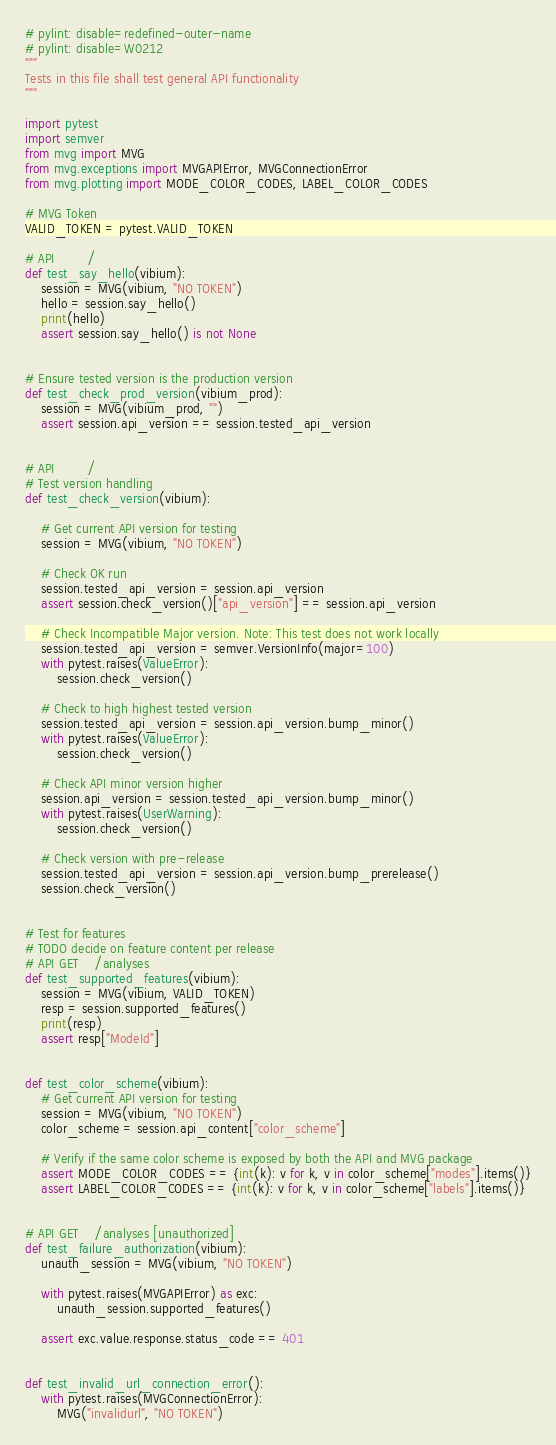<code> <loc_0><loc_0><loc_500><loc_500><_Python_># pylint: disable=redefined-outer-name
# pylint: disable=W0212
"""
Tests in this file shall test general API functionality
"""

import pytest
import semver
from mvg import MVG
from mvg.exceptions import MVGAPIError, MVGConnectionError
from mvg.plotting import MODE_COLOR_CODES, LABEL_COLOR_CODES

# MVG Token
VALID_TOKEN = pytest.VALID_TOKEN

# API        /
def test_say_hello(vibium):
    session = MVG(vibium, "NO TOKEN")
    hello = session.say_hello()
    print(hello)
    assert session.say_hello() is not None


# Ensure tested version is the production version
def test_check_prod_version(vibium_prod):
    session = MVG(vibium_prod, "")
    assert session.api_version == session.tested_api_version


# API        /
# Test version handling
def test_check_version(vibium):

    # Get current API version for testing
    session = MVG(vibium, "NO TOKEN")

    # Check OK run
    session.tested_api_version = session.api_version
    assert session.check_version()["api_version"] == session.api_version

    # Check Incompatible Major version. Note: This test does not work locally
    session.tested_api_version = semver.VersionInfo(major=100)
    with pytest.raises(ValueError):
        session.check_version()

    # Check to high highest tested version
    session.tested_api_version = session.api_version.bump_minor()
    with pytest.raises(ValueError):
        session.check_version()

    # Check API minor version higher
    session.api_version = session.tested_api_version.bump_minor()
    with pytest.raises(UserWarning):
        session.check_version()

    # Check version with pre-release
    session.tested_api_version = session.api_version.bump_prerelease()
    session.check_version()


# Test for features
# TODO decide on feature content per release
# API GET    /analyses
def test_supported_features(vibium):
    session = MVG(vibium, VALID_TOKEN)
    resp = session.supported_features()
    print(resp)
    assert resp["ModeId"]


def test_color_scheme(vibium):
    # Get current API version for testing
    session = MVG(vibium, "NO TOKEN")
    color_scheme = session.api_content["color_scheme"]

    # Verify if the same color scheme is exposed by both the API and MVG package
    assert MODE_COLOR_CODES == {int(k): v for k, v in color_scheme["modes"].items()}
    assert LABEL_COLOR_CODES == {int(k): v for k, v in color_scheme["labels"].items()}


# API GET    /analyses [unauthorized]
def test_failure_authorization(vibium):
    unauth_session = MVG(vibium, "NO TOKEN")

    with pytest.raises(MVGAPIError) as exc:
        unauth_session.supported_features()

    assert exc.value.response.status_code == 401


def test_invalid_url_connection_error():
    with pytest.raises(MVGConnectionError):
        MVG("invalidurl", "NO TOKEN")
</code> 